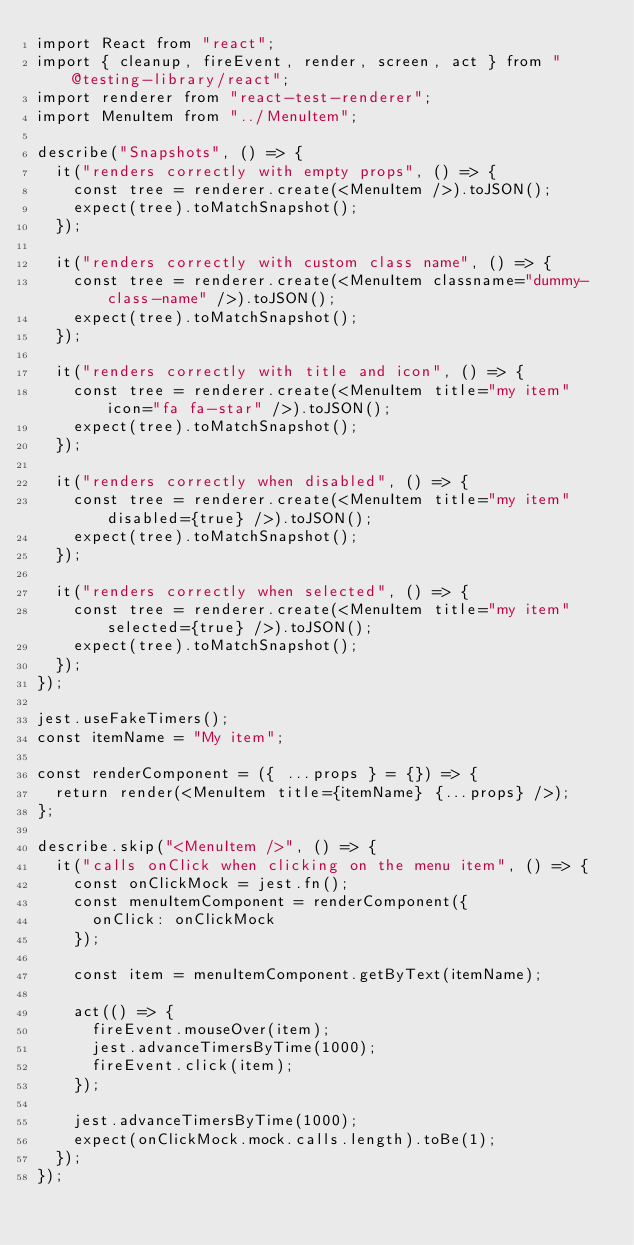<code> <loc_0><loc_0><loc_500><loc_500><_JavaScript_>import React from "react";
import { cleanup, fireEvent, render, screen, act } from "@testing-library/react";
import renderer from "react-test-renderer";
import MenuItem from "../MenuItem";

describe("Snapshots", () => {
  it("renders correctly with empty props", () => {
    const tree = renderer.create(<MenuItem />).toJSON();
    expect(tree).toMatchSnapshot();
  });

  it("renders correctly with custom class name", () => {
    const tree = renderer.create(<MenuItem classname="dummy-class-name" />).toJSON();
    expect(tree).toMatchSnapshot();
  });

  it("renders correctly with title and icon", () => {
    const tree = renderer.create(<MenuItem title="my item" icon="fa fa-star" />).toJSON();
    expect(tree).toMatchSnapshot();
  });

  it("renders correctly when disabled", () => {
    const tree = renderer.create(<MenuItem title="my item" disabled={true} />).toJSON();
    expect(tree).toMatchSnapshot();
  });

  it("renders correctly when selected", () => {
    const tree = renderer.create(<MenuItem title="my item" selected={true} />).toJSON();
    expect(tree).toMatchSnapshot();
  });
});

jest.useFakeTimers();
const itemName = "My item";

const renderComponent = ({ ...props } = {}) => {
  return render(<MenuItem title={itemName} {...props} />);
};

describe.skip("<MenuItem />", () => {
  it("calls onClick when clicking on the menu item", () => {
    const onClickMock = jest.fn();
    const menuItemComponent = renderComponent({
      onClick: onClickMock
    });

    const item = menuItemComponent.getByText(itemName);

    act(() => {
      fireEvent.mouseOver(item);
      jest.advanceTimersByTime(1000);
      fireEvent.click(item);
    });

    jest.advanceTimersByTime(1000);
    expect(onClickMock.mock.calls.length).toBe(1);
  });
});
</code> 